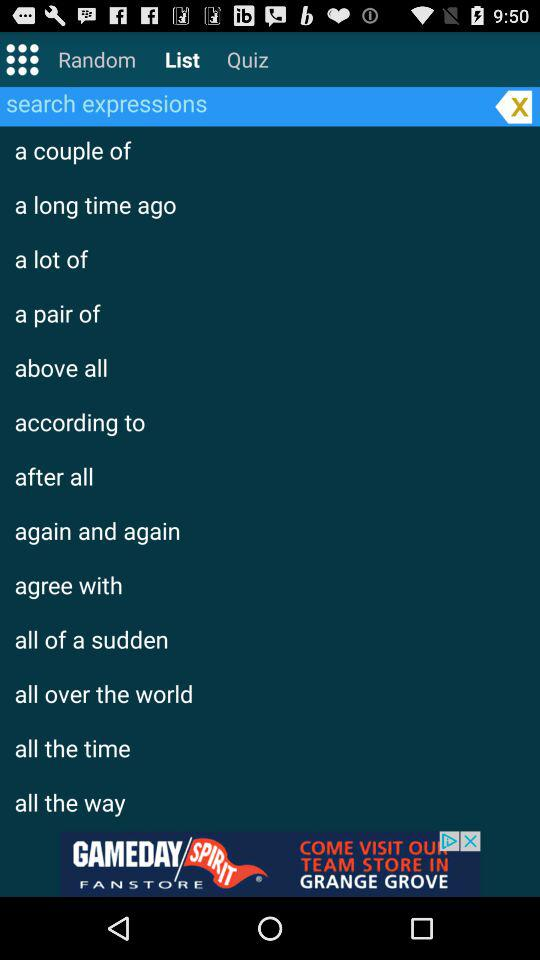How many quizzes have been completed?
When the provided information is insufficient, respond with <no answer>. <no answer> 